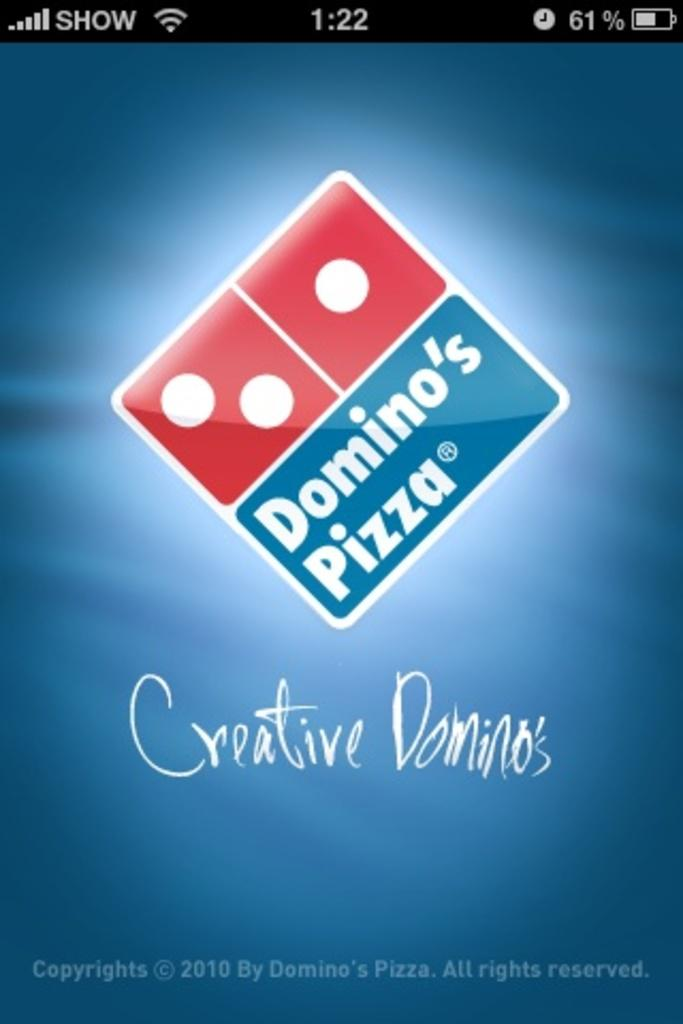<image>
Share a concise interpretation of the image provided. A domino pizza advertisement on a cell phone. 